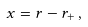<formula> <loc_0><loc_0><loc_500><loc_500>x = r - r _ { + } \, ,</formula> 